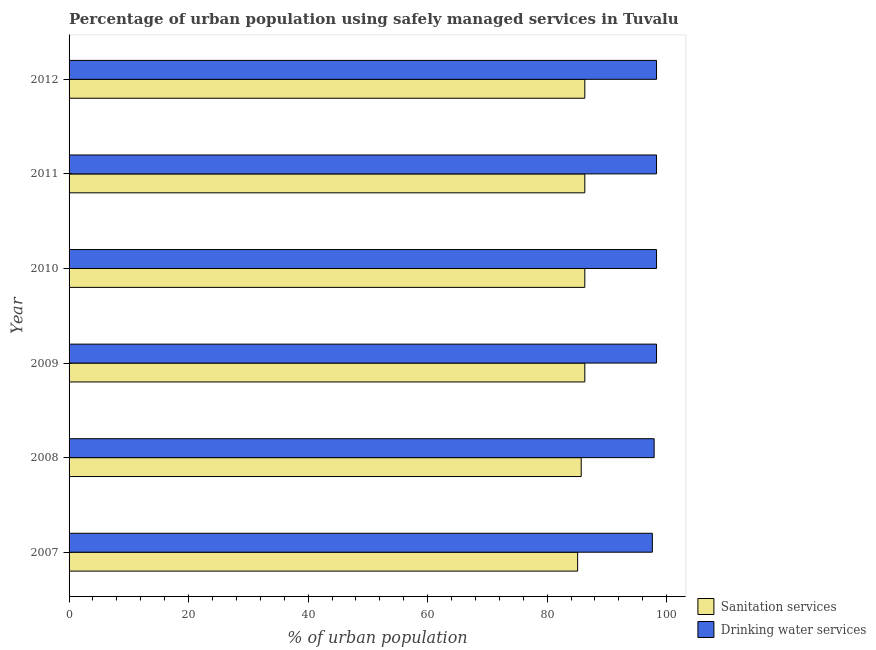How many groups of bars are there?
Offer a terse response. 6. Are the number of bars on each tick of the Y-axis equal?
Offer a terse response. Yes. How many bars are there on the 3rd tick from the bottom?
Your response must be concise. 2. In how many cases, is the number of bars for a given year not equal to the number of legend labels?
Ensure brevity in your answer.  0. What is the percentage of urban population who used sanitation services in 2011?
Give a very brief answer. 86.3. Across all years, what is the maximum percentage of urban population who used drinking water services?
Provide a succinct answer. 98.3. Across all years, what is the minimum percentage of urban population who used sanitation services?
Provide a short and direct response. 85.1. In which year was the percentage of urban population who used drinking water services maximum?
Make the answer very short. 2009. What is the total percentage of urban population who used sanitation services in the graph?
Keep it short and to the point. 516. What is the difference between the percentage of urban population who used drinking water services in 2010 and that in 2012?
Your response must be concise. 0. What is the difference between the percentage of urban population who used drinking water services in 2011 and the percentage of urban population who used sanitation services in 2008?
Offer a very short reply. 12.6. What is the average percentage of urban population who used drinking water services per year?
Ensure brevity in your answer.  98.12. Is the difference between the percentage of urban population who used drinking water services in 2009 and 2012 greater than the difference between the percentage of urban population who used sanitation services in 2009 and 2012?
Your answer should be very brief. No. In how many years, is the percentage of urban population who used drinking water services greater than the average percentage of urban population who used drinking water services taken over all years?
Your response must be concise. 4. What does the 1st bar from the top in 2007 represents?
Your answer should be compact. Drinking water services. What does the 1st bar from the bottom in 2009 represents?
Give a very brief answer. Sanitation services. How many bars are there?
Provide a succinct answer. 12. Are all the bars in the graph horizontal?
Offer a very short reply. Yes. What is the difference between two consecutive major ticks on the X-axis?
Your answer should be compact. 20. Does the graph contain any zero values?
Offer a very short reply. No. How many legend labels are there?
Give a very brief answer. 2. How are the legend labels stacked?
Offer a very short reply. Vertical. What is the title of the graph?
Ensure brevity in your answer.  Percentage of urban population using safely managed services in Tuvalu. Does "Depositors" appear as one of the legend labels in the graph?
Your response must be concise. No. What is the label or title of the X-axis?
Offer a terse response. % of urban population. What is the % of urban population in Sanitation services in 2007?
Your answer should be compact. 85.1. What is the % of urban population of Drinking water services in 2007?
Ensure brevity in your answer.  97.6. What is the % of urban population in Sanitation services in 2008?
Provide a short and direct response. 85.7. What is the % of urban population of Drinking water services in 2008?
Provide a short and direct response. 97.9. What is the % of urban population in Sanitation services in 2009?
Ensure brevity in your answer.  86.3. What is the % of urban population in Drinking water services in 2009?
Keep it short and to the point. 98.3. What is the % of urban population in Sanitation services in 2010?
Your answer should be very brief. 86.3. What is the % of urban population in Drinking water services in 2010?
Your response must be concise. 98.3. What is the % of urban population of Sanitation services in 2011?
Provide a succinct answer. 86.3. What is the % of urban population of Drinking water services in 2011?
Provide a short and direct response. 98.3. What is the % of urban population in Sanitation services in 2012?
Your answer should be compact. 86.3. What is the % of urban population of Drinking water services in 2012?
Ensure brevity in your answer.  98.3. Across all years, what is the maximum % of urban population in Sanitation services?
Ensure brevity in your answer.  86.3. Across all years, what is the maximum % of urban population of Drinking water services?
Offer a very short reply. 98.3. Across all years, what is the minimum % of urban population of Sanitation services?
Your answer should be compact. 85.1. Across all years, what is the minimum % of urban population in Drinking water services?
Provide a short and direct response. 97.6. What is the total % of urban population of Sanitation services in the graph?
Your answer should be compact. 516. What is the total % of urban population in Drinking water services in the graph?
Provide a short and direct response. 588.7. What is the difference between the % of urban population in Drinking water services in 2007 and that in 2009?
Your response must be concise. -0.7. What is the difference between the % of urban population in Sanitation services in 2007 and that in 2011?
Offer a very short reply. -1.2. What is the difference between the % of urban population of Drinking water services in 2007 and that in 2011?
Ensure brevity in your answer.  -0.7. What is the difference between the % of urban population in Sanitation services in 2007 and that in 2012?
Offer a very short reply. -1.2. What is the difference between the % of urban population of Drinking water services in 2008 and that in 2009?
Provide a succinct answer. -0.4. What is the difference between the % of urban population of Sanitation services in 2008 and that in 2010?
Ensure brevity in your answer.  -0.6. What is the difference between the % of urban population in Drinking water services in 2008 and that in 2010?
Give a very brief answer. -0.4. What is the difference between the % of urban population of Drinking water services in 2008 and that in 2011?
Keep it short and to the point. -0.4. What is the difference between the % of urban population of Drinking water services in 2009 and that in 2010?
Offer a terse response. 0. What is the difference between the % of urban population of Drinking water services in 2009 and that in 2011?
Give a very brief answer. 0. What is the difference between the % of urban population of Drinking water services in 2009 and that in 2012?
Your response must be concise. 0. What is the difference between the % of urban population in Sanitation services in 2011 and that in 2012?
Your answer should be very brief. 0. What is the difference between the % of urban population in Drinking water services in 2011 and that in 2012?
Offer a terse response. 0. What is the difference between the % of urban population in Sanitation services in 2007 and the % of urban population in Drinking water services in 2010?
Your response must be concise. -13.2. What is the difference between the % of urban population of Sanitation services in 2007 and the % of urban population of Drinking water services in 2012?
Your answer should be very brief. -13.2. What is the difference between the % of urban population of Sanitation services in 2008 and the % of urban population of Drinking water services in 2011?
Your answer should be very brief. -12.6. What is the difference between the % of urban population of Sanitation services in 2009 and the % of urban population of Drinking water services in 2010?
Provide a short and direct response. -12. What is the difference between the % of urban population of Sanitation services in 2009 and the % of urban population of Drinking water services in 2011?
Ensure brevity in your answer.  -12. What is the difference between the % of urban population in Sanitation services in 2009 and the % of urban population in Drinking water services in 2012?
Your answer should be very brief. -12. What is the difference between the % of urban population of Sanitation services in 2010 and the % of urban population of Drinking water services in 2012?
Give a very brief answer. -12. What is the difference between the % of urban population in Sanitation services in 2011 and the % of urban population in Drinking water services in 2012?
Provide a succinct answer. -12. What is the average % of urban population in Drinking water services per year?
Make the answer very short. 98.12. In the year 2009, what is the difference between the % of urban population of Sanitation services and % of urban population of Drinking water services?
Your response must be concise. -12. In the year 2010, what is the difference between the % of urban population of Sanitation services and % of urban population of Drinking water services?
Provide a short and direct response. -12. In the year 2011, what is the difference between the % of urban population of Sanitation services and % of urban population of Drinking water services?
Offer a very short reply. -12. What is the ratio of the % of urban population in Sanitation services in 2007 to that in 2008?
Keep it short and to the point. 0.99. What is the ratio of the % of urban population of Drinking water services in 2007 to that in 2008?
Your response must be concise. 1. What is the ratio of the % of urban population in Sanitation services in 2007 to that in 2009?
Make the answer very short. 0.99. What is the ratio of the % of urban population in Sanitation services in 2007 to that in 2010?
Ensure brevity in your answer.  0.99. What is the ratio of the % of urban population in Drinking water services in 2007 to that in 2010?
Give a very brief answer. 0.99. What is the ratio of the % of urban population of Sanitation services in 2007 to that in 2011?
Your response must be concise. 0.99. What is the ratio of the % of urban population in Drinking water services in 2007 to that in 2011?
Ensure brevity in your answer.  0.99. What is the ratio of the % of urban population in Sanitation services in 2007 to that in 2012?
Your answer should be very brief. 0.99. What is the ratio of the % of urban population in Sanitation services in 2008 to that in 2009?
Give a very brief answer. 0.99. What is the ratio of the % of urban population of Drinking water services in 2008 to that in 2010?
Your answer should be very brief. 1. What is the ratio of the % of urban population in Drinking water services in 2008 to that in 2011?
Provide a short and direct response. 1. What is the ratio of the % of urban population of Drinking water services in 2009 to that in 2010?
Keep it short and to the point. 1. What is the ratio of the % of urban population of Drinking water services in 2009 to that in 2011?
Offer a terse response. 1. What is the ratio of the % of urban population of Sanitation services in 2009 to that in 2012?
Give a very brief answer. 1. What is the ratio of the % of urban population in Drinking water services in 2010 to that in 2012?
Give a very brief answer. 1. What is the difference between the highest and the lowest % of urban population in Sanitation services?
Offer a terse response. 1.2. What is the difference between the highest and the lowest % of urban population in Drinking water services?
Provide a succinct answer. 0.7. 